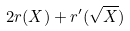Convert formula to latex. <formula><loc_0><loc_0><loc_500><loc_500>2 r ( X ) + r ^ { \prime } ( \sqrt { X } )</formula> 